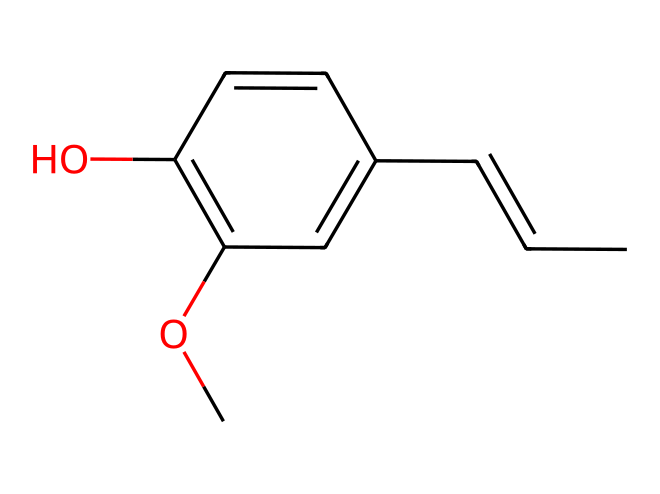What is the molecular formula of eugenol? To derive the molecular formula, count all the carbon (C), hydrogen (H), and oxygen (O) atoms in the SMILES representation. There are 10 carbon atoms, 12 hydrogen atoms, and 2 oxygen atoms. Therefore, the molecular formula is C10H12O2.
Answer: C10H12O2 How many rings are present in the structure of eugenol? Analyzing the SMILES representation, there is one cyclic structure which is indicated by the use of "C1" indicating the start of a ring. Thus, there is one ring present in eugenol.
Answer: 1 What functional groups are present in eugenol? Upon examining the structure, eugenol contains a phenolic hydroxyl group (-OH) and an ether group (-O-), which can be identified from the hydroxyl attached directly to the aromatic ring and another -O- in the structure. Thus, both groups are present.
Answer: phenolic hydroxyl and ether What is the total number of hydrogen atoms bonded to the phenyl ring in eugenol? The phenyl ring, part of eugenol, refers to the aromatic system. Counting the hydrogen atoms bonded to the carbons involved in the ring shows that there are 5 hydrogen atoms attached to the ring due to the substitutions made by the hydroxyl and methoxy groups.
Answer: 5 Which type of aromatic compound is eugenol classified as? Eugenol is classified as a phenolic compound because of the presence of the -OH group directly attached to the aromatic phenyl ring structure, which characterizes phenolic compounds.
Answer: phenolic compound How many oxygen atoms are present in the eugenol molecule? From the molecular formula derived earlier, there are 2 oxygen atoms present in eugenol. Counting directly from the structural representation, we also confirm this.
Answer: 2 